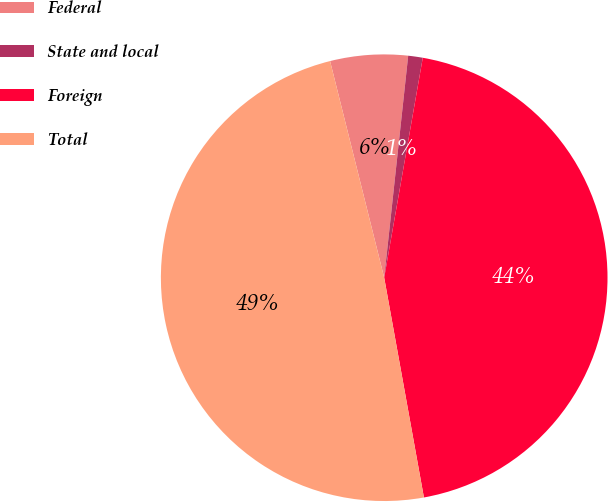<chart> <loc_0><loc_0><loc_500><loc_500><pie_chart><fcel>Federal<fcel>State and local<fcel>Foreign<fcel>Total<nl><fcel>5.61%<fcel>1.05%<fcel>44.39%<fcel>48.95%<nl></chart> 